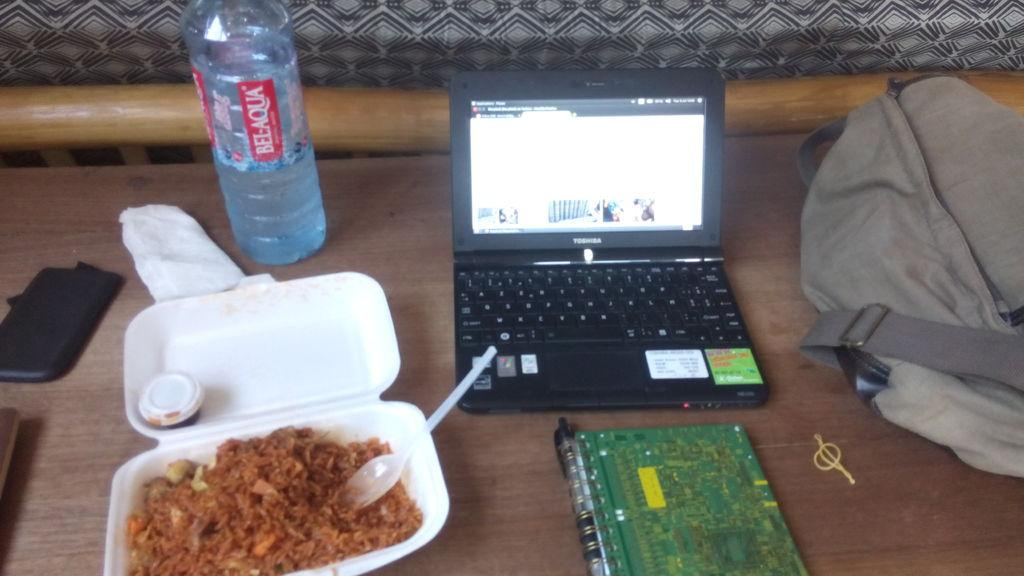<image>
Provide a brief description of the given image. A laptop, a meal and a large bottle of Bel Aqua water. 